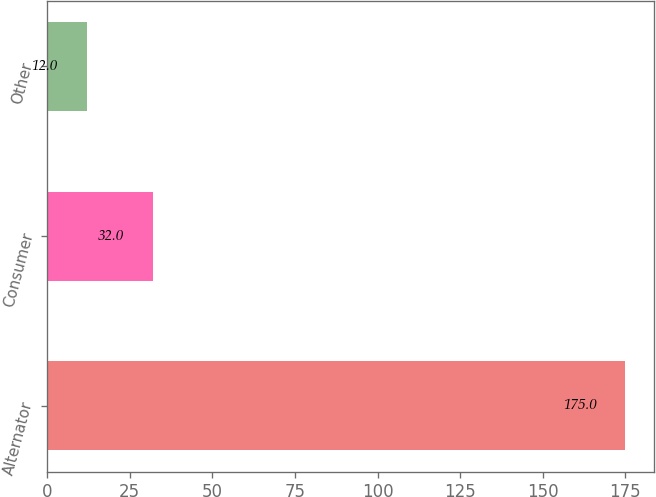Convert chart to OTSL. <chart><loc_0><loc_0><loc_500><loc_500><bar_chart><fcel>Alternator<fcel>Consumer<fcel>Other<nl><fcel>175<fcel>32<fcel>12<nl></chart> 